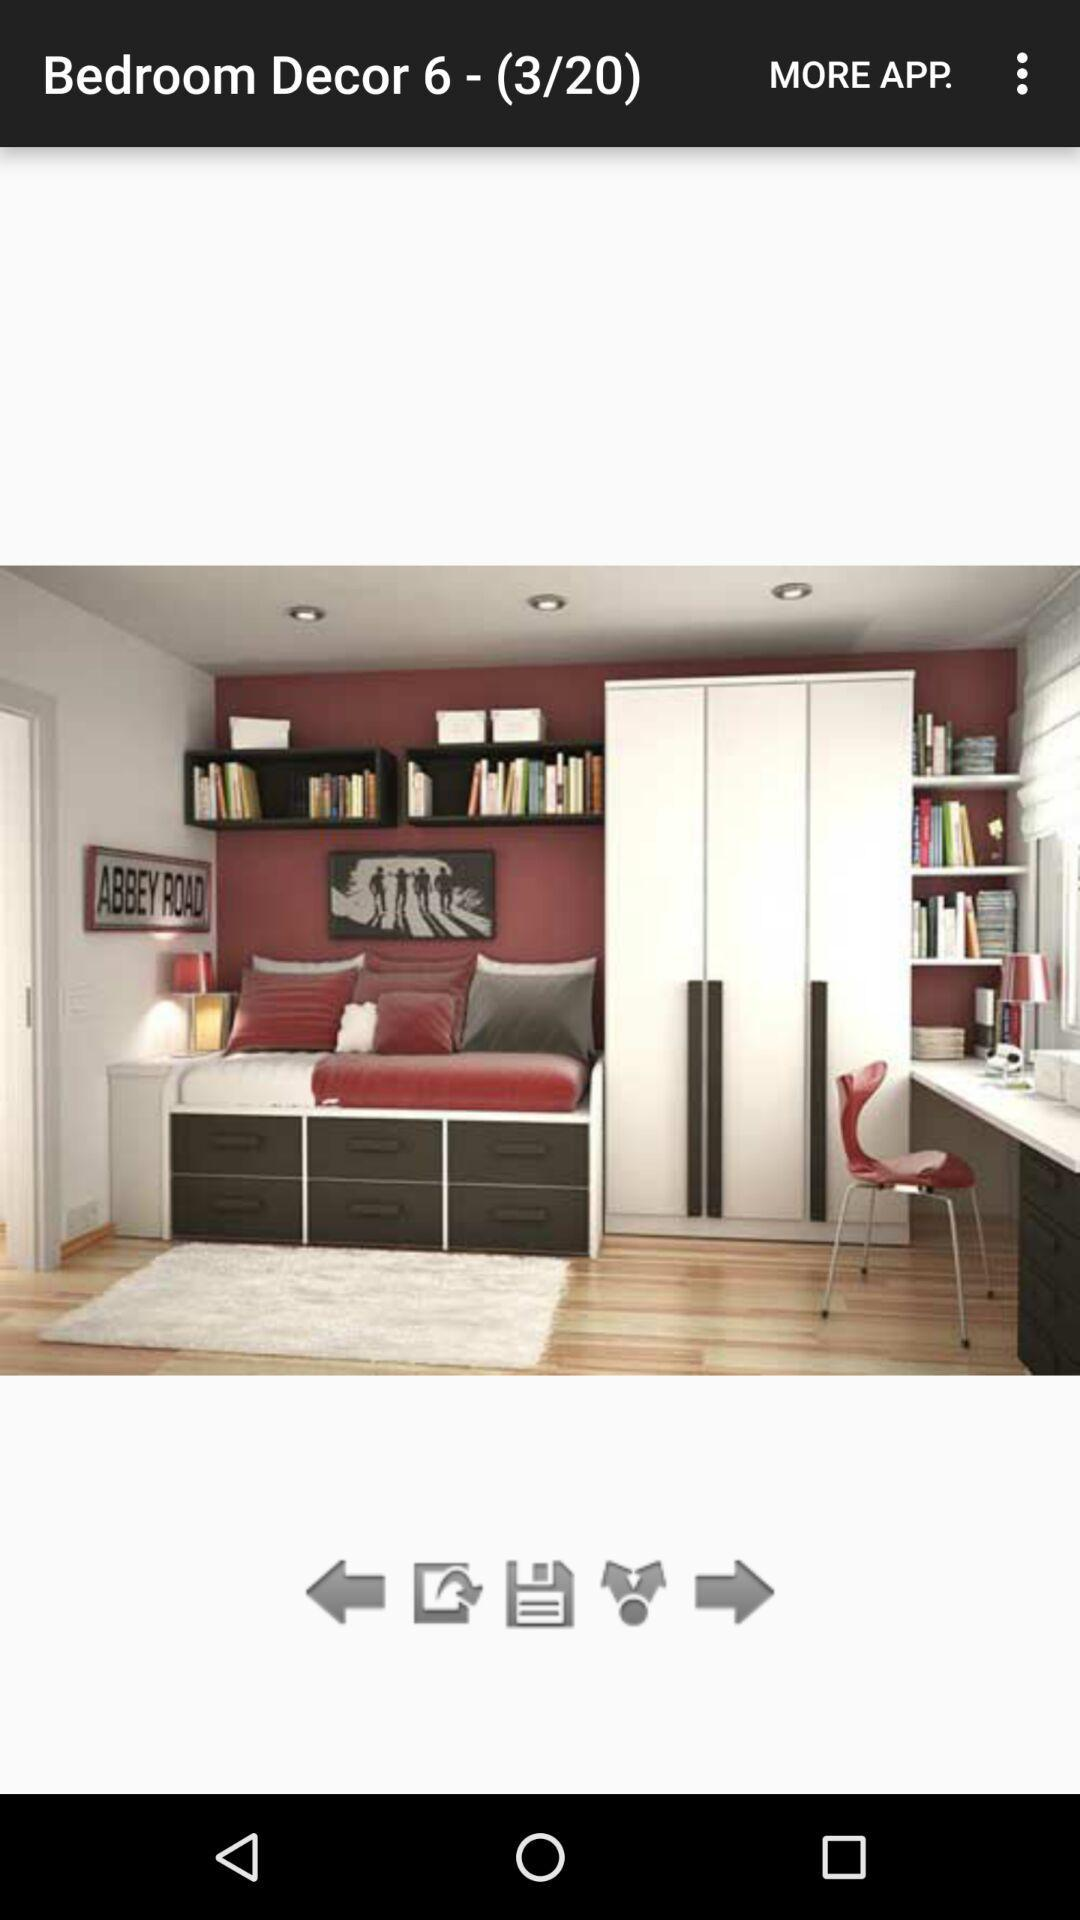What is the total number of images? The total number of images is 20. 